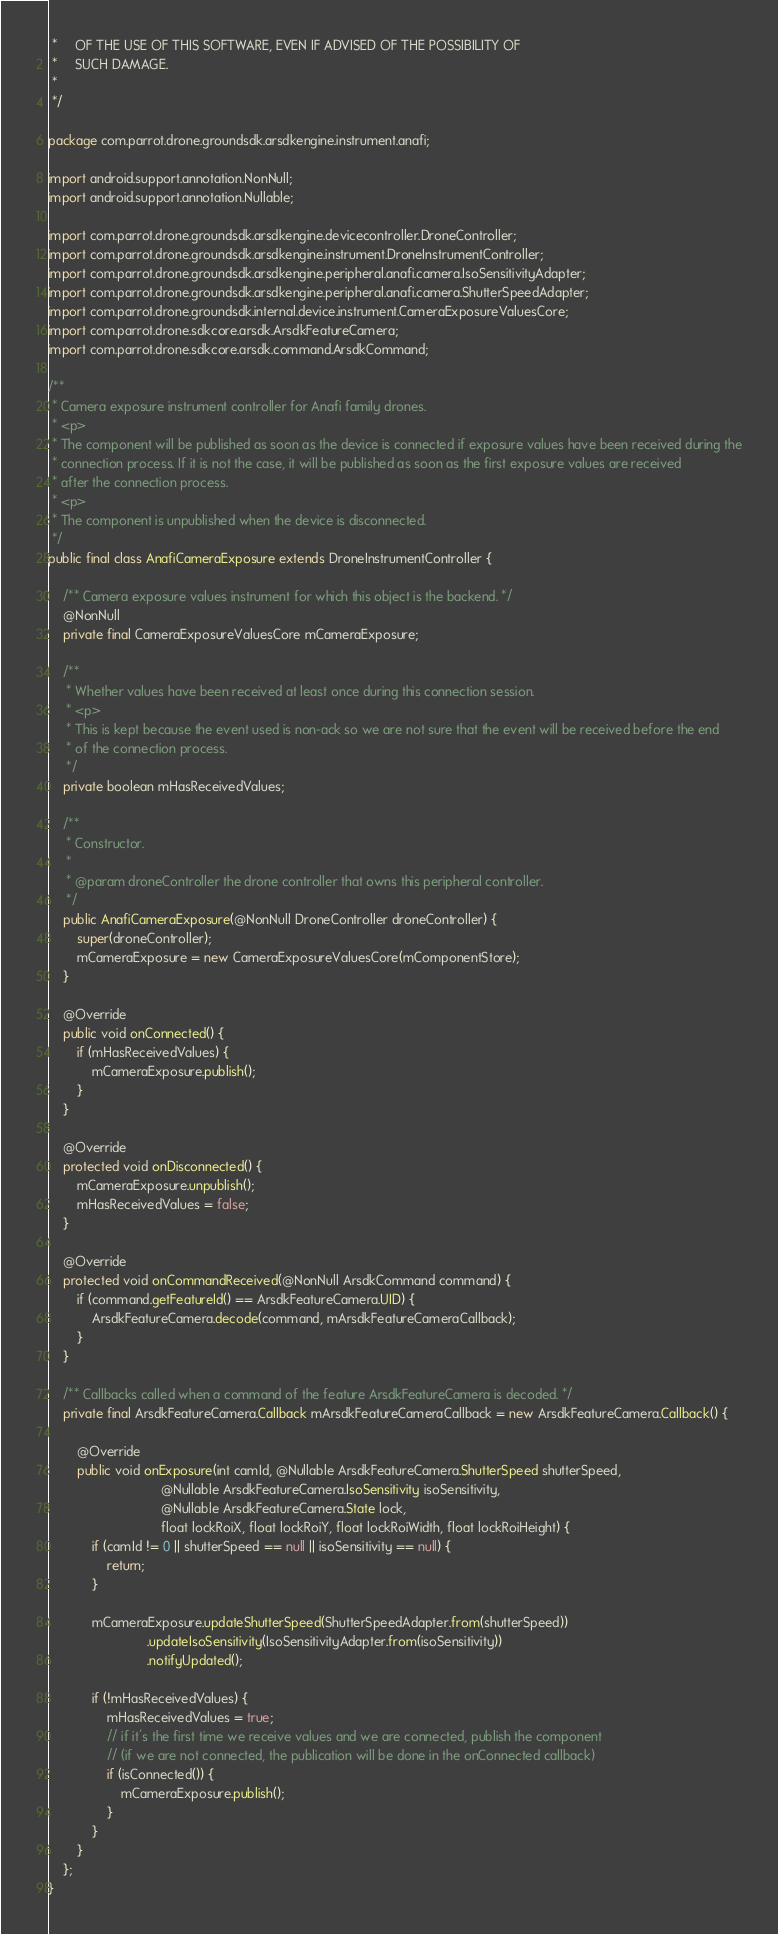<code> <loc_0><loc_0><loc_500><loc_500><_Java_> *     OF THE USE OF THIS SOFTWARE, EVEN IF ADVISED OF THE POSSIBILITY OF
 *     SUCH DAMAGE.
 *
 */

package com.parrot.drone.groundsdk.arsdkengine.instrument.anafi;

import android.support.annotation.NonNull;
import android.support.annotation.Nullable;

import com.parrot.drone.groundsdk.arsdkengine.devicecontroller.DroneController;
import com.parrot.drone.groundsdk.arsdkengine.instrument.DroneInstrumentController;
import com.parrot.drone.groundsdk.arsdkengine.peripheral.anafi.camera.IsoSensitivityAdapter;
import com.parrot.drone.groundsdk.arsdkengine.peripheral.anafi.camera.ShutterSpeedAdapter;
import com.parrot.drone.groundsdk.internal.device.instrument.CameraExposureValuesCore;
import com.parrot.drone.sdkcore.arsdk.ArsdkFeatureCamera;
import com.parrot.drone.sdkcore.arsdk.command.ArsdkCommand;

/**
 * Camera exposure instrument controller for Anafi family drones.
 * <p>
 * The component will be published as soon as the device is connected if exposure values have been received during the
 * connection process. If it is not the case, it will be published as soon as the first exposure values are received
 * after the connection process.
 * <p>
 * The component is unpublished when the device is disconnected.
 */
public final class AnafiCameraExposure extends DroneInstrumentController {

    /** Camera exposure values instrument for which this object is the backend. */
    @NonNull
    private final CameraExposureValuesCore mCameraExposure;

    /**
     * Whether values have been received at least once during this connection session.
     * <p>
     * This is kept because the event used is non-ack so we are not sure that the event will be received before the end
     * of the connection process.
     */
    private boolean mHasReceivedValues;

    /**
     * Constructor.
     *
     * @param droneController the drone controller that owns this peripheral controller.
     */
    public AnafiCameraExposure(@NonNull DroneController droneController) {
        super(droneController);
        mCameraExposure = new CameraExposureValuesCore(mComponentStore);
    }

    @Override
    public void onConnected() {
        if (mHasReceivedValues) {
            mCameraExposure.publish();
        }
    }

    @Override
    protected void onDisconnected() {
        mCameraExposure.unpublish();
        mHasReceivedValues = false;
    }

    @Override
    protected void onCommandReceived(@NonNull ArsdkCommand command) {
        if (command.getFeatureId() == ArsdkFeatureCamera.UID) {
            ArsdkFeatureCamera.decode(command, mArsdkFeatureCameraCallback);
        }
    }

    /** Callbacks called when a command of the feature ArsdkFeatureCamera is decoded. */
    private final ArsdkFeatureCamera.Callback mArsdkFeatureCameraCallback = new ArsdkFeatureCamera.Callback() {

        @Override
        public void onExposure(int camId, @Nullable ArsdkFeatureCamera.ShutterSpeed shutterSpeed,
                               @Nullable ArsdkFeatureCamera.IsoSensitivity isoSensitivity,
                               @Nullable ArsdkFeatureCamera.State lock,
                               float lockRoiX, float lockRoiY, float lockRoiWidth, float lockRoiHeight) {
            if (camId != 0 || shutterSpeed == null || isoSensitivity == null) {
                return;
            }

            mCameraExposure.updateShutterSpeed(ShutterSpeedAdapter.from(shutterSpeed))
                           .updateIsoSensitivity(IsoSensitivityAdapter.from(isoSensitivity))
                           .notifyUpdated();

            if (!mHasReceivedValues) {
                mHasReceivedValues = true;
                // if it's the first time we receive values and we are connected, publish the component
                // (if we are not connected, the publication will be done in the onConnected callback)
                if (isConnected()) {
                    mCameraExposure.publish();
                }
            }
        }
    };
}
</code> 